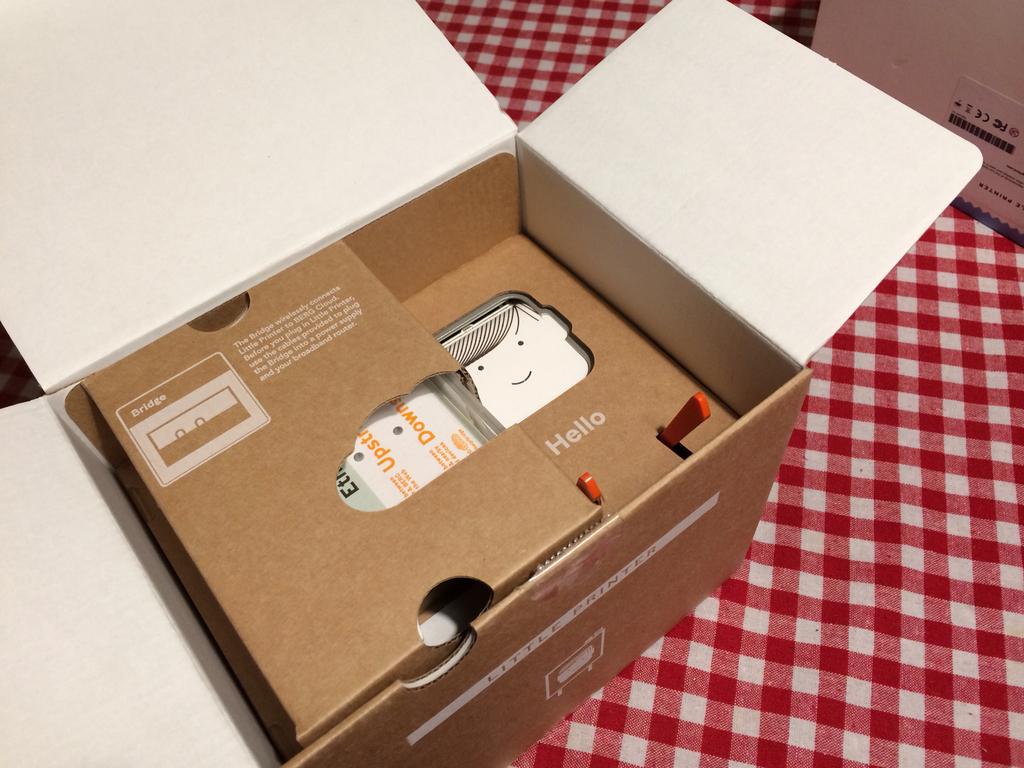What greeting is shown in the box?
Your response must be concise. Hello. 